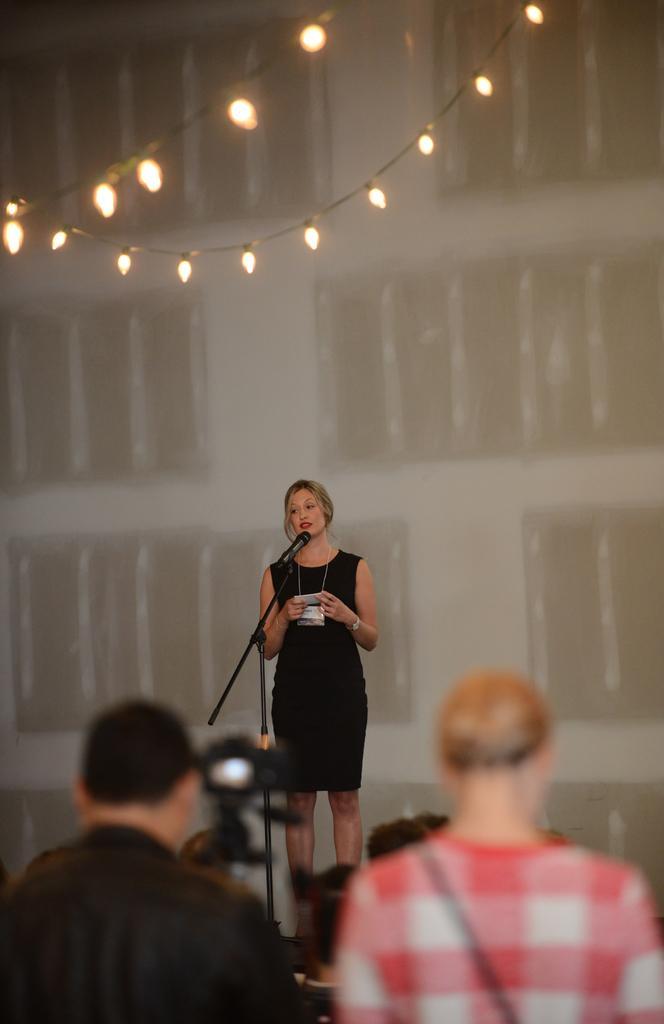Can you describe this image briefly? In this picture I can see a camera, there are few people, there is a mike with a mike stand, there is a woman standing, there are lights, and in the background it looks like a board or a wall. 